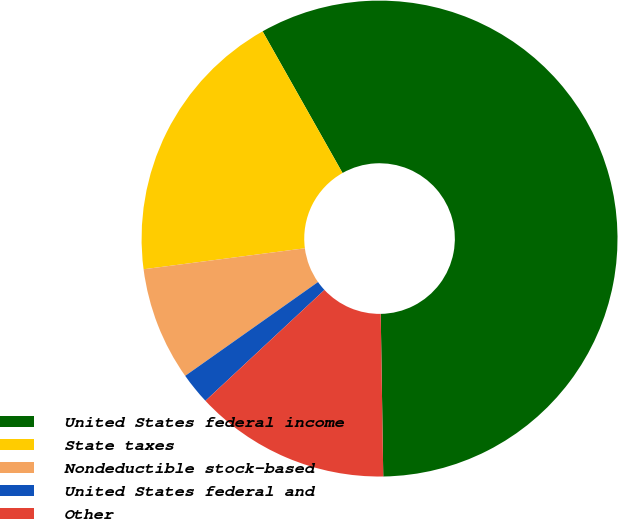<chart> <loc_0><loc_0><loc_500><loc_500><pie_chart><fcel>United States federal income<fcel>State taxes<fcel>Nondeductible stock-based<fcel>United States federal and<fcel>Other<nl><fcel>57.93%<fcel>18.88%<fcel>7.73%<fcel>2.15%<fcel>13.31%<nl></chart> 